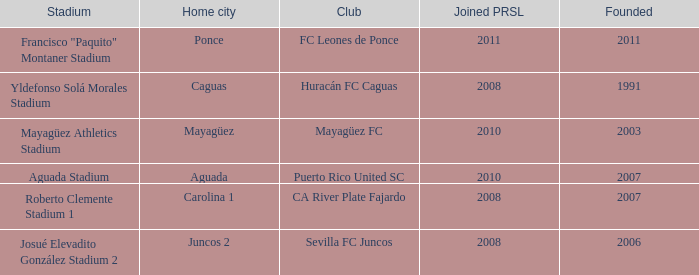What is the earliest founded when the home city is mayagüez? 2003.0. 